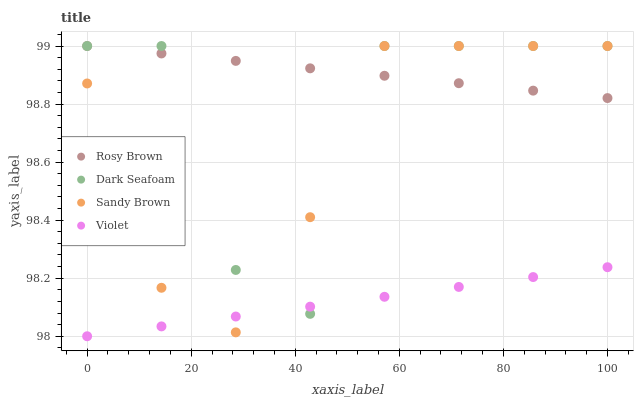Does Violet have the minimum area under the curve?
Answer yes or no. Yes. Does Rosy Brown have the maximum area under the curve?
Answer yes or no. Yes. Does Sandy Brown have the minimum area under the curve?
Answer yes or no. No. Does Sandy Brown have the maximum area under the curve?
Answer yes or no. No. Is Rosy Brown the smoothest?
Answer yes or no. Yes. Is Dark Seafoam the roughest?
Answer yes or no. Yes. Is Sandy Brown the smoothest?
Answer yes or no. No. Is Sandy Brown the roughest?
Answer yes or no. No. Does Violet have the lowest value?
Answer yes or no. Yes. Does Sandy Brown have the lowest value?
Answer yes or no. No. Does Sandy Brown have the highest value?
Answer yes or no. Yes. Does Violet have the highest value?
Answer yes or no. No. Is Violet less than Rosy Brown?
Answer yes or no. Yes. Is Rosy Brown greater than Violet?
Answer yes or no. Yes. Does Dark Seafoam intersect Sandy Brown?
Answer yes or no. Yes. Is Dark Seafoam less than Sandy Brown?
Answer yes or no. No. Is Dark Seafoam greater than Sandy Brown?
Answer yes or no. No. Does Violet intersect Rosy Brown?
Answer yes or no. No. 